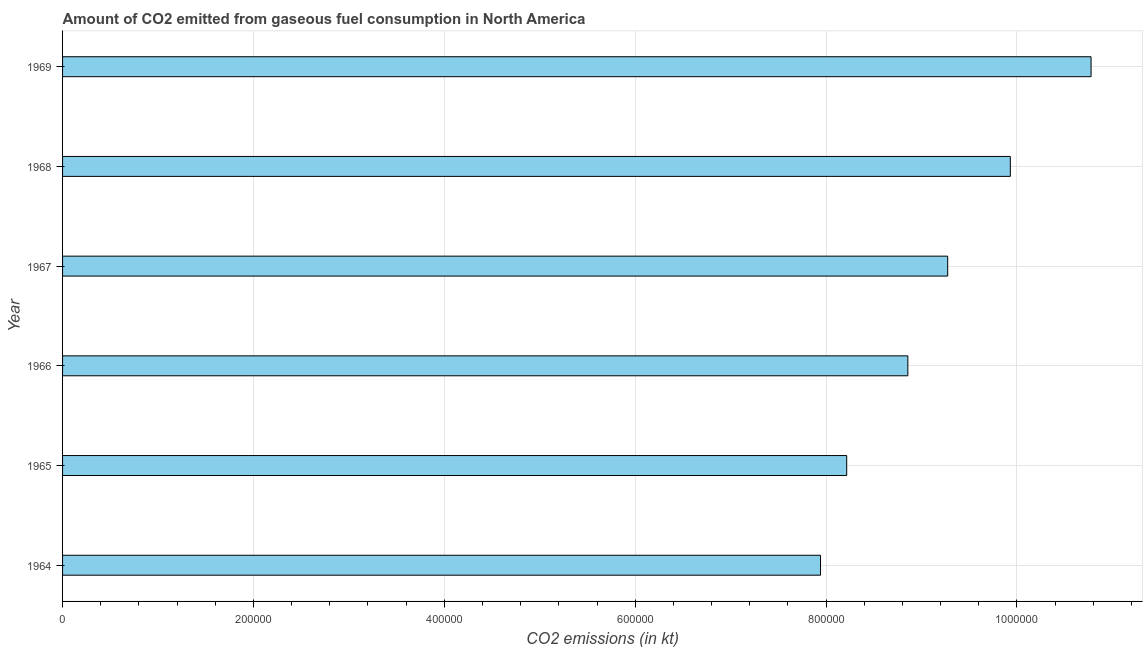Does the graph contain any zero values?
Make the answer very short. No. Does the graph contain grids?
Your response must be concise. Yes. What is the title of the graph?
Your response must be concise. Amount of CO2 emitted from gaseous fuel consumption in North America. What is the label or title of the X-axis?
Offer a terse response. CO2 emissions (in kt). What is the label or title of the Y-axis?
Give a very brief answer. Year. What is the co2 emissions from gaseous fuel consumption in 1968?
Provide a succinct answer. 9.93e+05. Across all years, what is the maximum co2 emissions from gaseous fuel consumption?
Offer a terse response. 1.08e+06. Across all years, what is the minimum co2 emissions from gaseous fuel consumption?
Offer a very short reply. 7.94e+05. In which year was the co2 emissions from gaseous fuel consumption maximum?
Ensure brevity in your answer.  1969. In which year was the co2 emissions from gaseous fuel consumption minimum?
Keep it short and to the point. 1964. What is the sum of the co2 emissions from gaseous fuel consumption?
Offer a terse response. 5.50e+06. What is the difference between the co2 emissions from gaseous fuel consumption in 1965 and 1967?
Your answer should be compact. -1.06e+05. What is the average co2 emissions from gaseous fuel consumption per year?
Keep it short and to the point. 9.17e+05. What is the median co2 emissions from gaseous fuel consumption?
Provide a short and direct response. 9.07e+05. What is the ratio of the co2 emissions from gaseous fuel consumption in 1966 to that in 1969?
Ensure brevity in your answer.  0.82. What is the difference between the highest and the second highest co2 emissions from gaseous fuel consumption?
Your response must be concise. 8.46e+04. Is the sum of the co2 emissions from gaseous fuel consumption in 1964 and 1965 greater than the maximum co2 emissions from gaseous fuel consumption across all years?
Give a very brief answer. Yes. What is the difference between the highest and the lowest co2 emissions from gaseous fuel consumption?
Ensure brevity in your answer.  2.84e+05. In how many years, is the co2 emissions from gaseous fuel consumption greater than the average co2 emissions from gaseous fuel consumption taken over all years?
Provide a short and direct response. 3. What is the difference between two consecutive major ticks on the X-axis?
Give a very brief answer. 2.00e+05. Are the values on the major ticks of X-axis written in scientific E-notation?
Make the answer very short. No. What is the CO2 emissions (in kt) in 1964?
Your answer should be compact. 7.94e+05. What is the CO2 emissions (in kt) in 1965?
Your answer should be very brief. 8.22e+05. What is the CO2 emissions (in kt) in 1966?
Give a very brief answer. 8.86e+05. What is the CO2 emissions (in kt) in 1967?
Offer a terse response. 9.27e+05. What is the CO2 emissions (in kt) of 1968?
Offer a very short reply. 9.93e+05. What is the CO2 emissions (in kt) of 1969?
Make the answer very short. 1.08e+06. What is the difference between the CO2 emissions (in kt) in 1964 and 1965?
Ensure brevity in your answer.  -2.74e+04. What is the difference between the CO2 emissions (in kt) in 1964 and 1966?
Your response must be concise. -9.15e+04. What is the difference between the CO2 emissions (in kt) in 1964 and 1967?
Ensure brevity in your answer.  -1.33e+05. What is the difference between the CO2 emissions (in kt) in 1964 and 1968?
Provide a succinct answer. -1.99e+05. What is the difference between the CO2 emissions (in kt) in 1964 and 1969?
Offer a terse response. -2.84e+05. What is the difference between the CO2 emissions (in kt) in 1965 and 1966?
Give a very brief answer. -6.41e+04. What is the difference between the CO2 emissions (in kt) in 1965 and 1967?
Ensure brevity in your answer.  -1.06e+05. What is the difference between the CO2 emissions (in kt) in 1965 and 1968?
Offer a very short reply. -1.71e+05. What is the difference between the CO2 emissions (in kt) in 1965 and 1969?
Offer a terse response. -2.56e+05. What is the difference between the CO2 emissions (in kt) in 1966 and 1967?
Your answer should be very brief. -4.18e+04. What is the difference between the CO2 emissions (in kt) in 1966 and 1968?
Offer a very short reply. -1.07e+05. What is the difference between the CO2 emissions (in kt) in 1966 and 1969?
Your response must be concise. -1.92e+05. What is the difference between the CO2 emissions (in kt) in 1967 and 1968?
Offer a very short reply. -6.56e+04. What is the difference between the CO2 emissions (in kt) in 1967 and 1969?
Offer a very short reply. -1.50e+05. What is the difference between the CO2 emissions (in kt) in 1968 and 1969?
Provide a succinct answer. -8.46e+04. What is the ratio of the CO2 emissions (in kt) in 1964 to that in 1966?
Give a very brief answer. 0.9. What is the ratio of the CO2 emissions (in kt) in 1964 to that in 1967?
Provide a short and direct response. 0.86. What is the ratio of the CO2 emissions (in kt) in 1964 to that in 1968?
Make the answer very short. 0.8. What is the ratio of the CO2 emissions (in kt) in 1964 to that in 1969?
Give a very brief answer. 0.74. What is the ratio of the CO2 emissions (in kt) in 1965 to that in 1966?
Provide a succinct answer. 0.93. What is the ratio of the CO2 emissions (in kt) in 1965 to that in 1967?
Offer a terse response. 0.89. What is the ratio of the CO2 emissions (in kt) in 1965 to that in 1968?
Your response must be concise. 0.83. What is the ratio of the CO2 emissions (in kt) in 1965 to that in 1969?
Keep it short and to the point. 0.76. What is the ratio of the CO2 emissions (in kt) in 1966 to that in 1967?
Offer a terse response. 0.95. What is the ratio of the CO2 emissions (in kt) in 1966 to that in 1968?
Make the answer very short. 0.89. What is the ratio of the CO2 emissions (in kt) in 1966 to that in 1969?
Offer a very short reply. 0.82. What is the ratio of the CO2 emissions (in kt) in 1967 to that in 1968?
Provide a succinct answer. 0.93. What is the ratio of the CO2 emissions (in kt) in 1967 to that in 1969?
Your answer should be very brief. 0.86. What is the ratio of the CO2 emissions (in kt) in 1968 to that in 1969?
Ensure brevity in your answer.  0.92. 